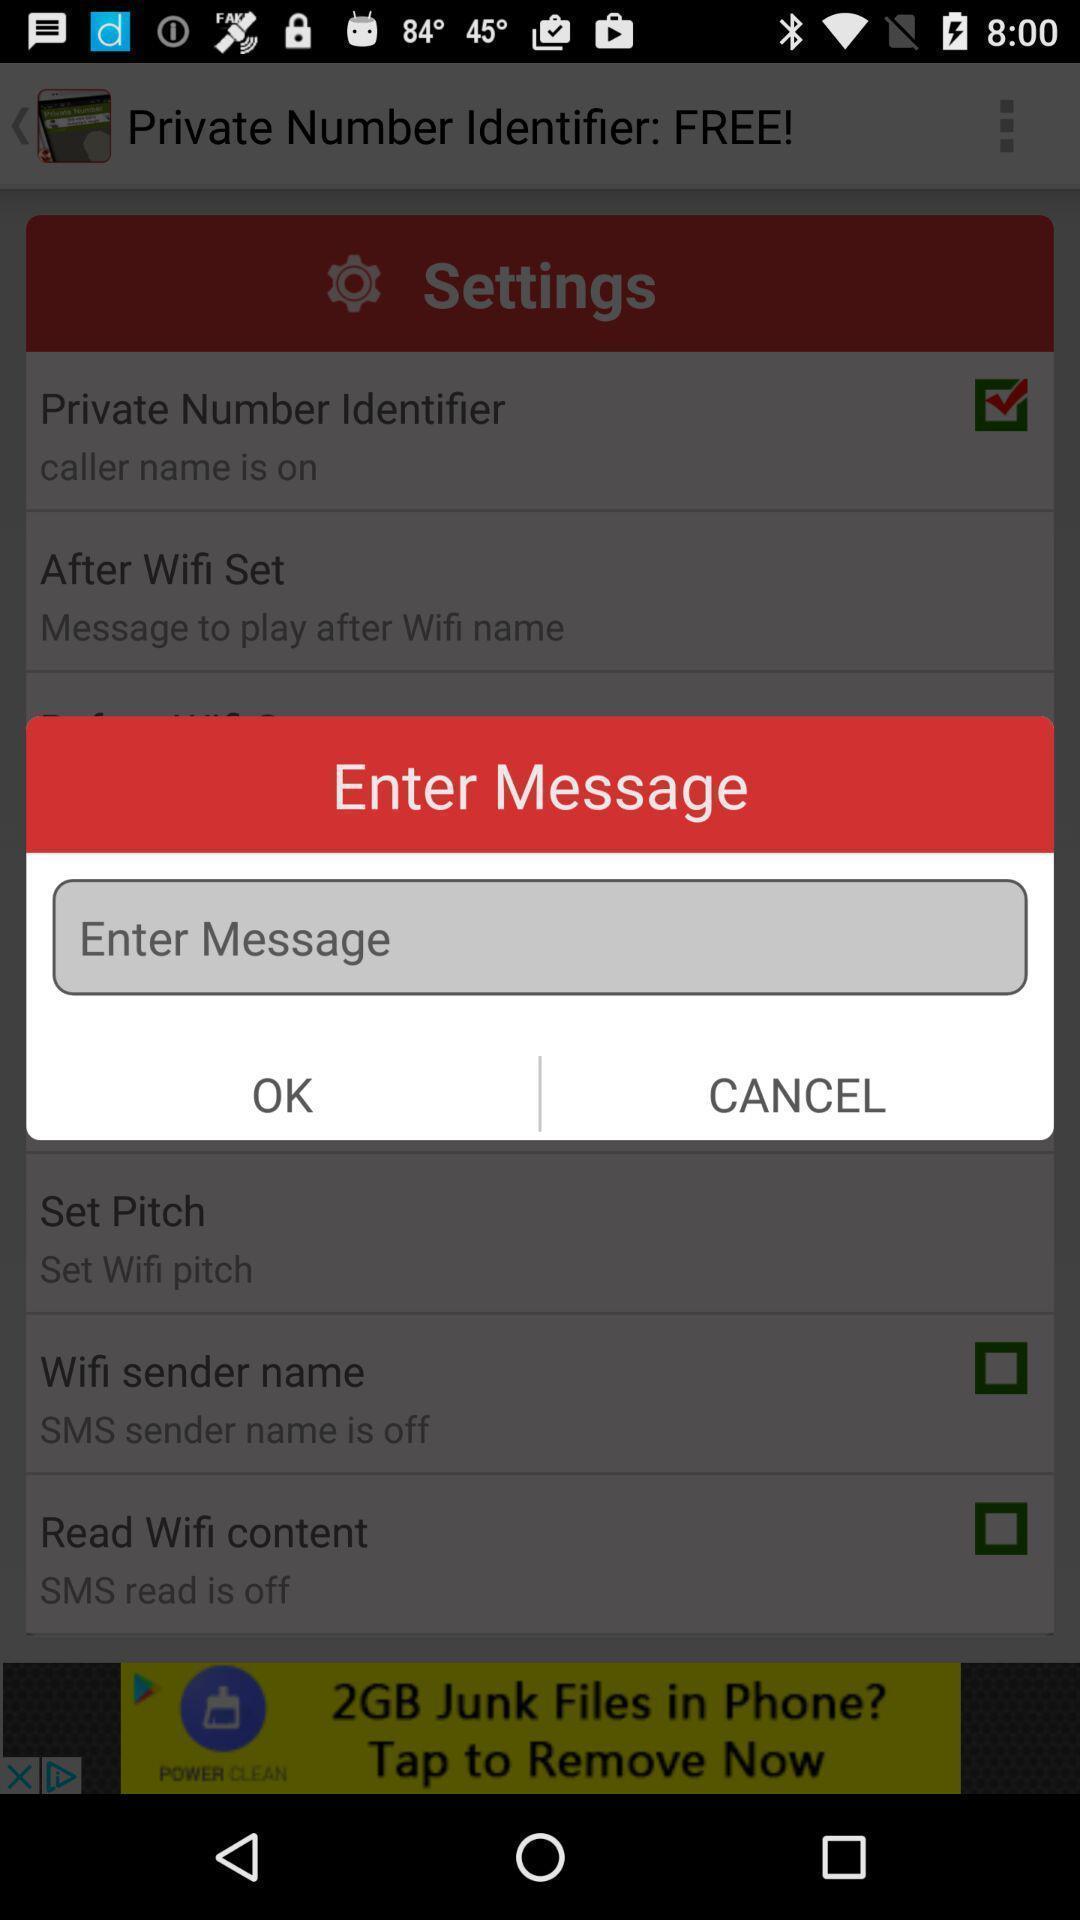Provide a textual representation of this image. Pop up to enter a message. 